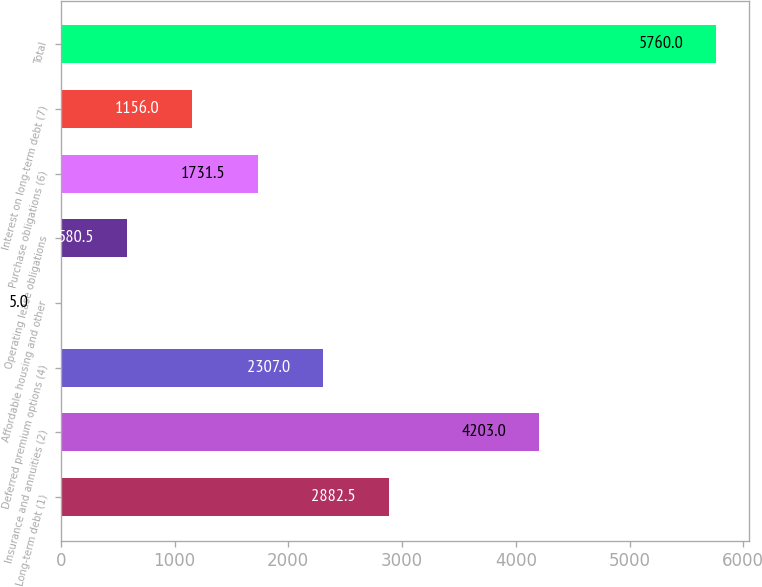Convert chart. <chart><loc_0><loc_0><loc_500><loc_500><bar_chart><fcel>Long-term debt (1)<fcel>Insurance and annuities (2)<fcel>Deferred premium options (4)<fcel>Affordable housing and other<fcel>Operating lease obligations<fcel>Purchase obligations (6)<fcel>Interest on long-term debt (7)<fcel>Total<nl><fcel>2882.5<fcel>4203<fcel>2307<fcel>5<fcel>580.5<fcel>1731.5<fcel>1156<fcel>5760<nl></chart> 